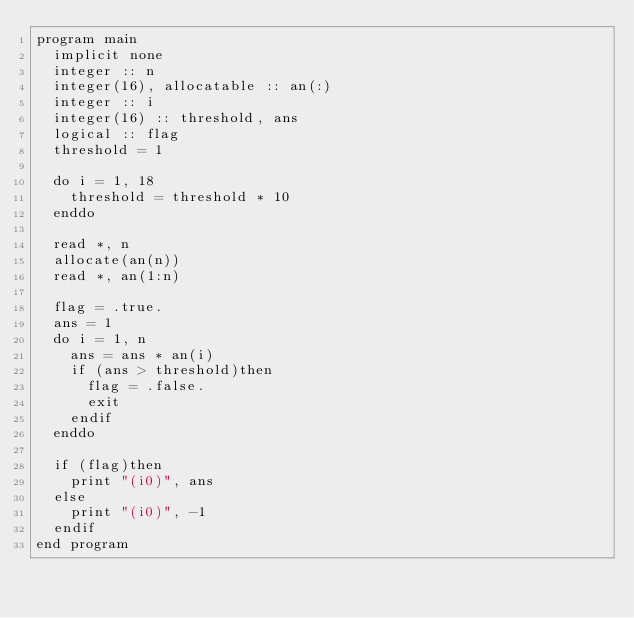<code> <loc_0><loc_0><loc_500><loc_500><_FORTRAN_>program main
  implicit none
  integer :: n
  integer(16), allocatable :: an(:)
  integer :: i
  integer(16) :: threshold, ans
  logical :: flag
  threshold = 1

  do i = 1, 18
    threshold = threshold * 10
  enddo

  read *, n
  allocate(an(n))
  read *, an(1:n)

  flag = .true.
  ans = 1
  do i = 1, n
    ans = ans * an(i)
    if (ans > threshold)then
      flag = .false.
      exit
    endif
  enddo

  if (flag)then
    print "(i0)", ans
  else
    print "(i0)", -1
  endif
end program</code> 